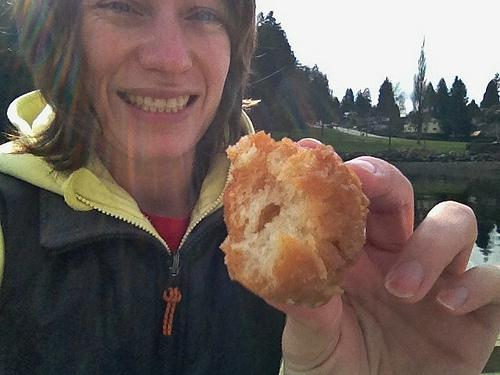Question: what is the woman doing in the picture?
Choices:
A. Talking.
B. Laughing.
C. Eating.
D. Drinking.
Answer with the letter. Answer: C Question: what is she eating?
Choices:
A. A muffin.
B. A cookie.
C. A cupcake.
D. A piece of chocolate.
Answer with the letter. Answer: A Question: where are the tall trees in the picture?
Choices:
A. In the foreground of the picture.
B. On the right of the picture.
C. In the back of the picture.
D. On the left of the picture.
Answer with the letter. Answer: C Question: what color is her zipper pull?
Choices:
A. Black.
B. Orange.
C. White.
D. Silver.
Answer with the letter. Answer: B 